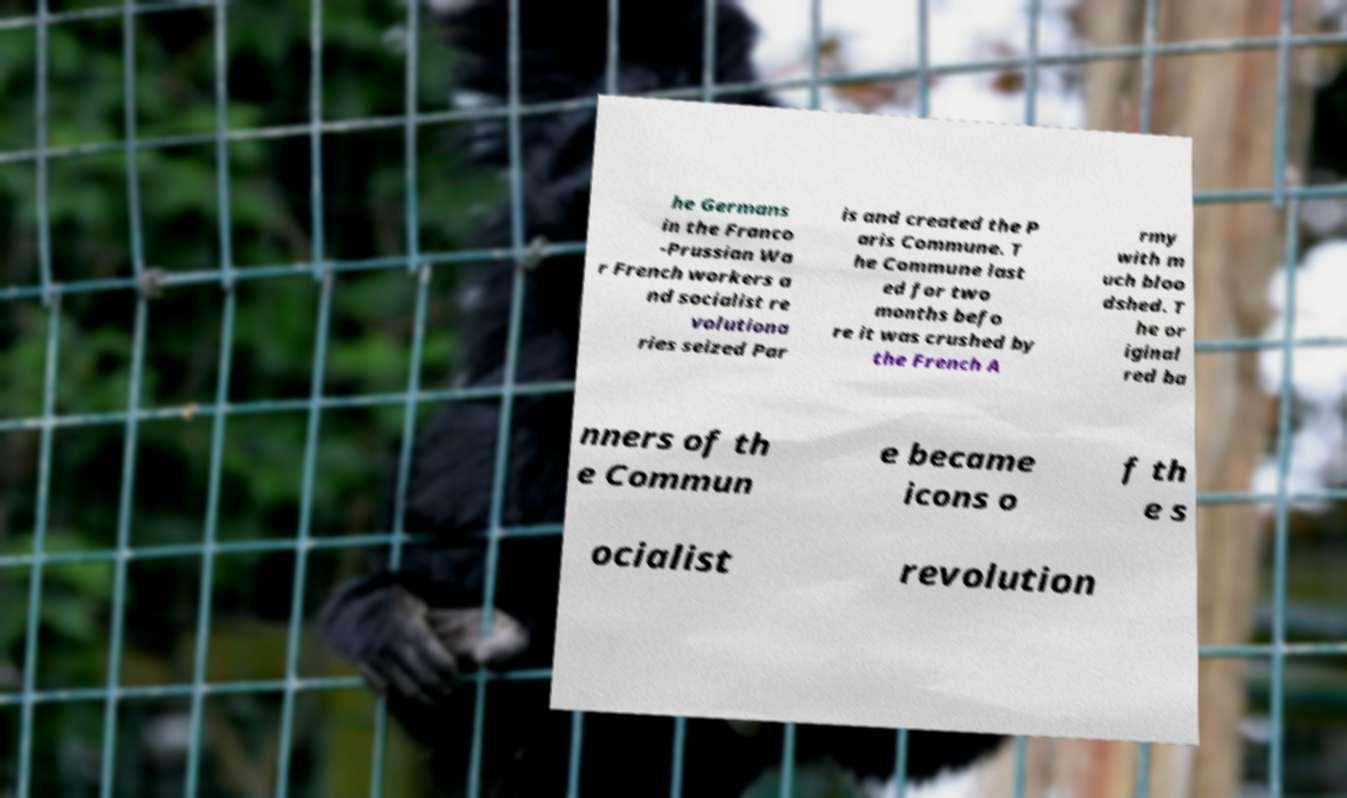Can you read and provide the text displayed in the image?This photo seems to have some interesting text. Can you extract and type it out for me? he Germans in the Franco -Prussian Wa r French workers a nd socialist re volutiona ries seized Par is and created the P aris Commune. T he Commune last ed for two months befo re it was crushed by the French A rmy with m uch bloo dshed. T he or iginal red ba nners of th e Commun e became icons o f th e s ocialist revolution 